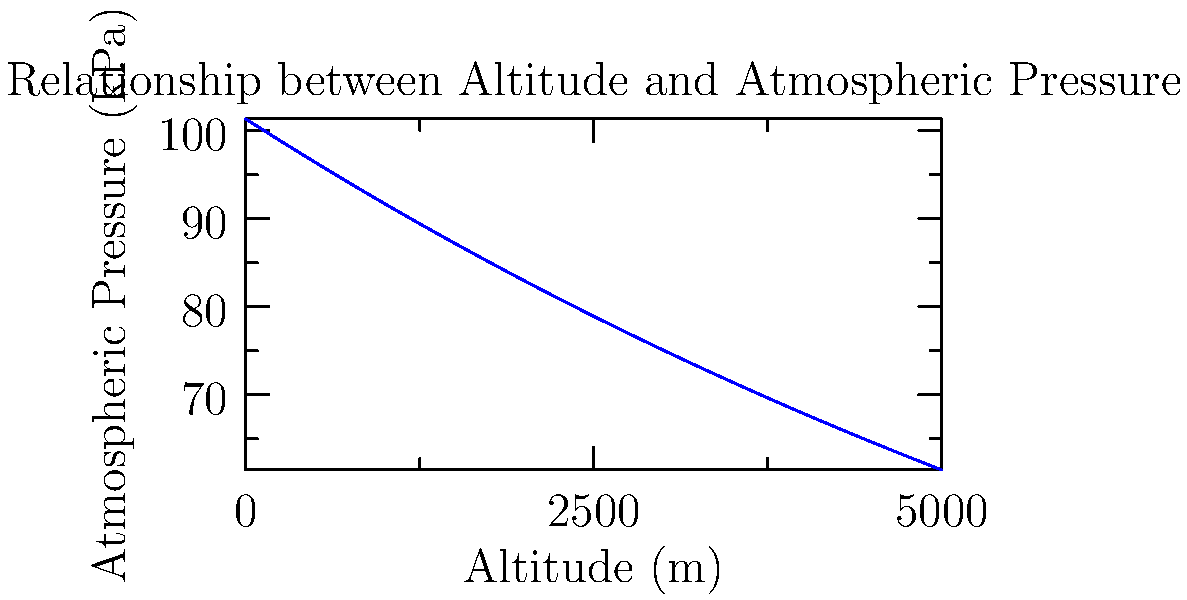As an avid hiker, you're planning a trek to a mountain peak at 4000m elevation. Using the graph, estimate the atmospheric pressure at your destination. How does this compare to the pressure at sea level (101.325 kPa), and what implications might this have for your hiking experience? To solve this problem, let's follow these steps:

1. Locate 4000m on the x-axis (Altitude).
2. Find the corresponding point on the curve.
3. Read the y-value (Atmospheric Pressure) for this point.

From the graph, we can estimate that at 4000m, the atmospheric pressure is approximately 62 kPa.

To compare with sea level:
1. Calculate the difference: $101.325 \text{ kPa} - 62 \text{ kPa} = 39.325 \text{ kPa}$
2. Calculate the percentage decrease: $\frac{39.325}{101.325} \times 100\% \approx 38.8\%$

The atmospheric pressure at 4000m is about 38.8% lower than at sea level.

Implications for hiking:
1. Less oxygen per breath due to lower air pressure.
2. Potential for altitude sickness.
3. Faster dehydration due to increased respiration rate.
4. Cooler temperatures at higher altitudes.
5. Possibly more UV radiation exposure.

As a hiker, you should prepare for these conditions by:
- Acclimatizing gradually to higher altitudes
- Staying well-hydrated
- Using sun protection
- Packing appropriate clothing for cooler temperatures
- Being aware of altitude sickness symptoms
Answer: 62 kPa; 38.8% lower than sea level; less oxygen, risk of altitude sickness, faster dehydration. 